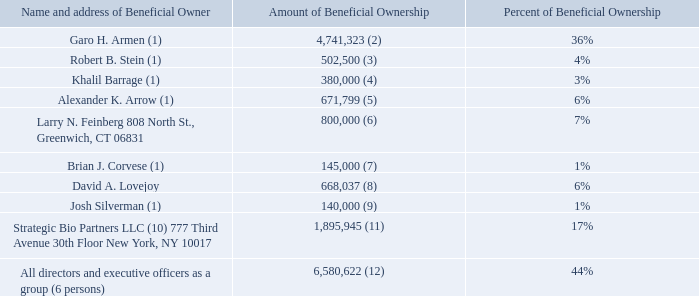Security Ownership of Certain Beneficial Owners and Management
The following table summarizes the beneficial owners of more than 5% of the Company’s voting securities and the securities of the Company beneficially owned by the Company’s directors and officers as of April 27, 2020.
What is the amount and percent of beneficial ownership owned by Garo H. Armen?  4,741,323, 36%. What is the amount and percent of beneficial ownership owned by Robert B. Stein? 502,500, 4%. What is the amount and percent of beneficial ownership owned by Khalil Barrage? 380,000, 3%. Who owns the largest percent of beneficial ownership? Obtained from the table
Answer: garo h. armen. Who owns the smallest percent of beneficial ownership? Obtained from the table
Answer: josh silverman. What is the proportion of Josh Silverman's beneficial ownership as a percentage of Larry N. Feinberg's beneficial ownership?
Answer scale should be: percent. 140,000/800,000 
Answer: 17.5. 